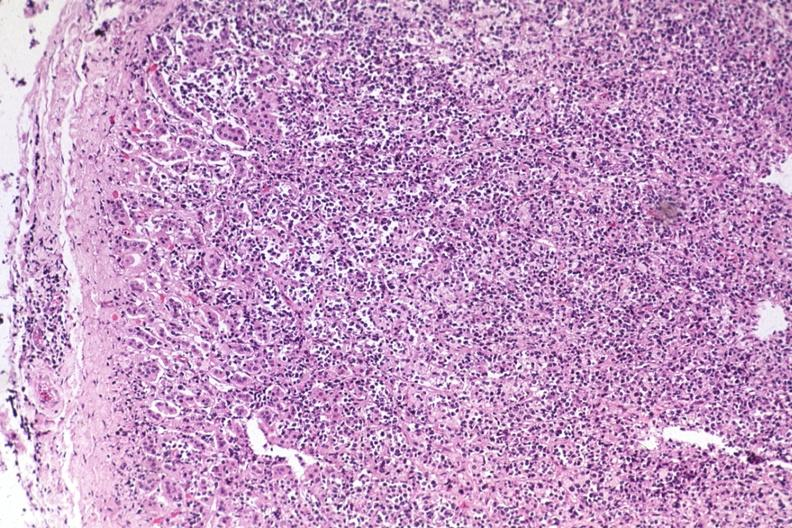s polycystic disease present?
Answer the question using a single word or phrase. No 